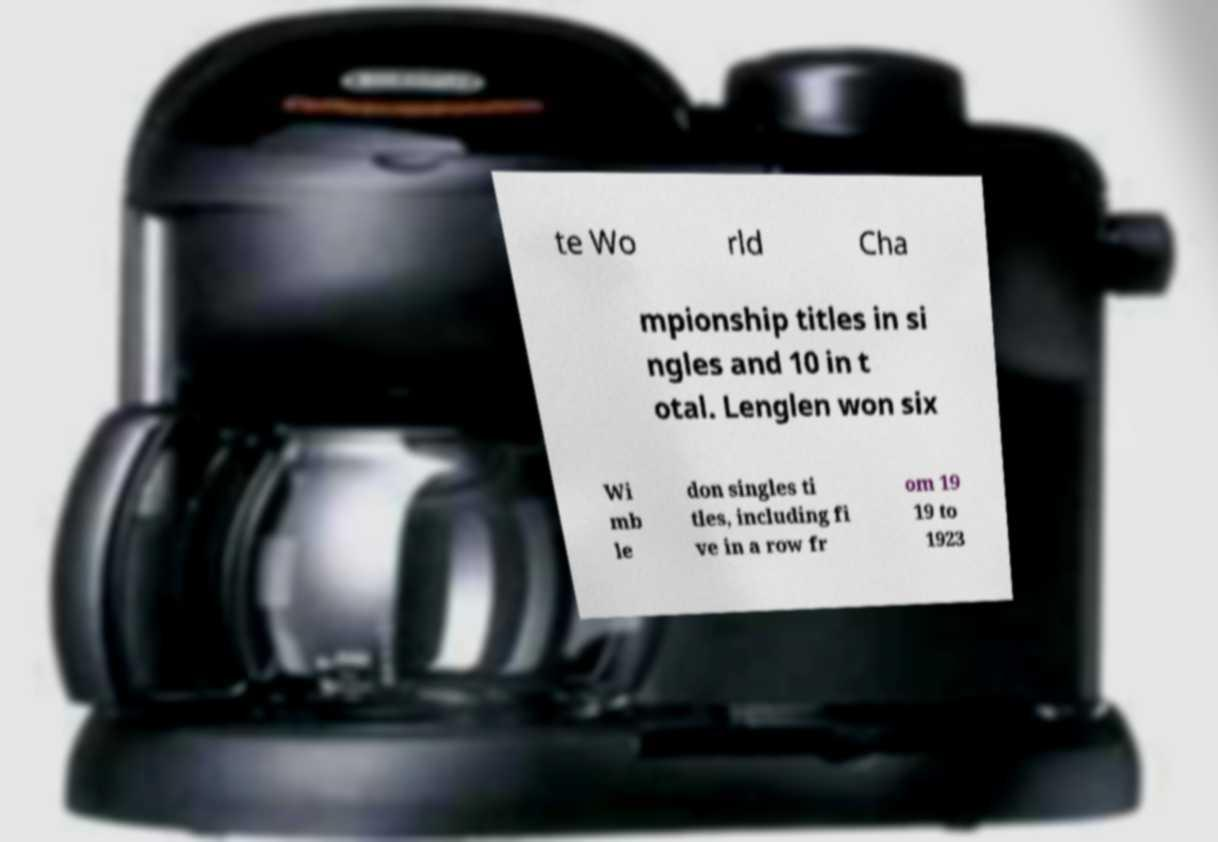Could you assist in decoding the text presented in this image and type it out clearly? te Wo rld Cha mpionship titles in si ngles and 10 in t otal. Lenglen won six Wi mb le don singles ti tles, including fi ve in a row fr om 19 19 to 1923 